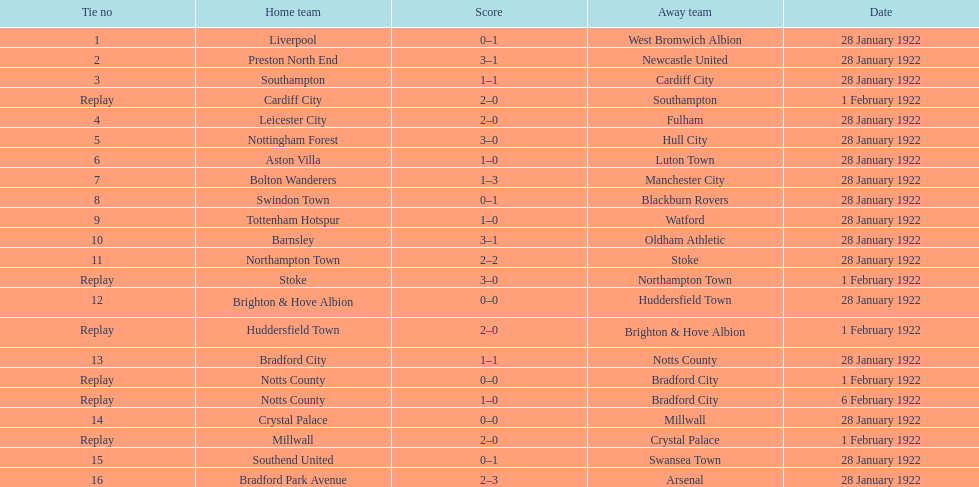How many games had no points registered? 3. 